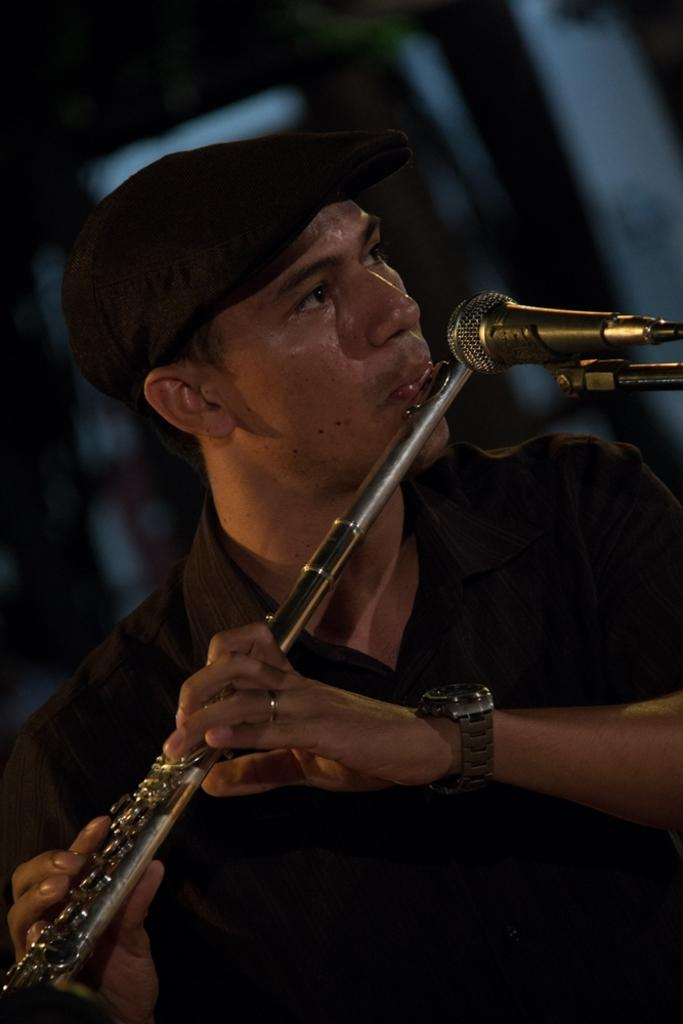What is the main subject of the image? The main subject of the image is a man. What is the man holding in his hand? The man is holding a flute in his hand. What type of apparatus can be seen in the image? There is no apparatus present in the image; it features a man holding a flute. How many beds are visible in the image? There are no beds visible in the image. 